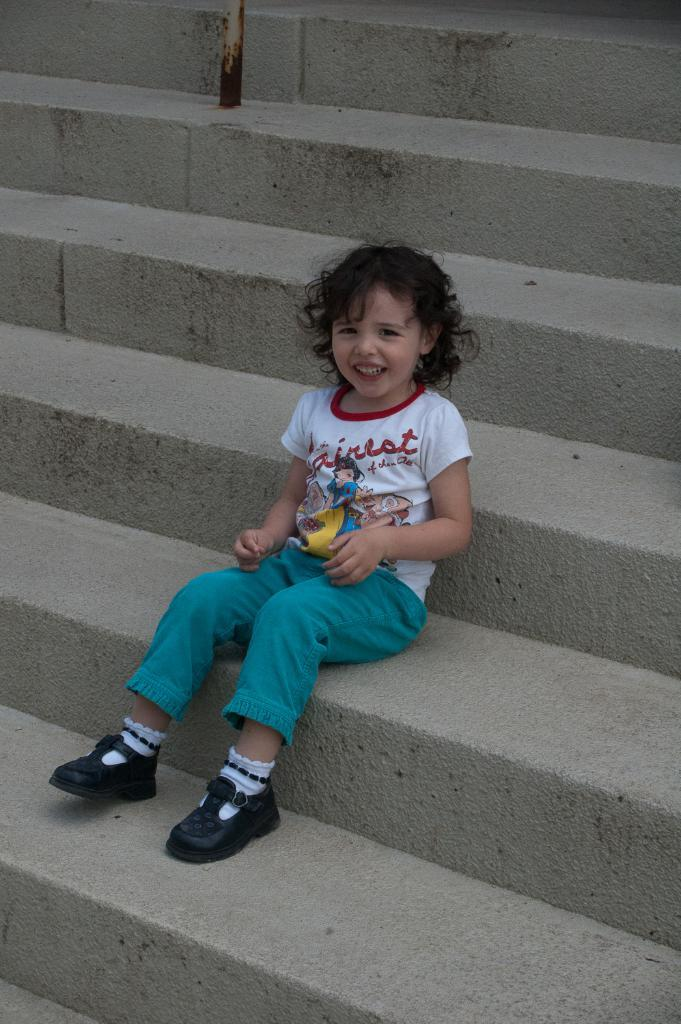What is the person in the image doing? The person is sitting in the image. What is the person wearing? The person is wearing a white and blue color dress. What can be seen in the background of the image? There are stairs visible in the background of the image. What type of canvas is the person painting on in the image? There is no canvas or painting activity present in the image. 